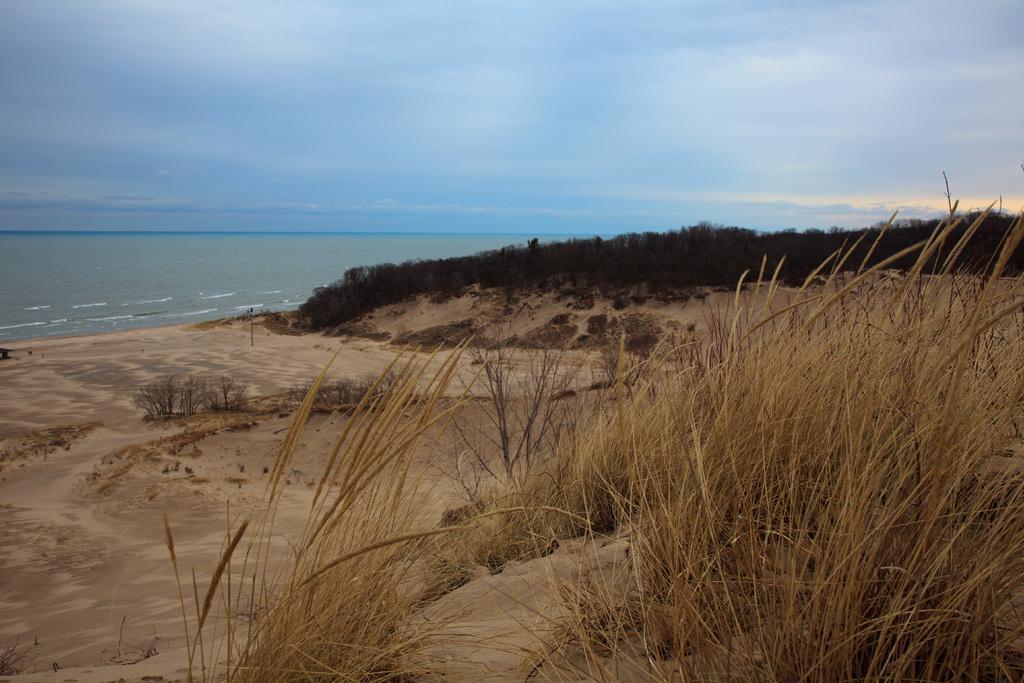In one or two sentences, can you explain what this image depicts? In this picture I can see the open area, trees, plants and grass. In the background I can see the ocean. At the top I can see the sky and clouds. 